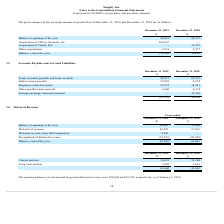According to Shopify's financial document, What is the current portion of deferred revenue in 2019? According to the financial document, 56,691 (in thousands). The relevant text states: "Current portion 56,691 39,180..." Also, What was the January 1, 2018 opening balance of current deferred revenue? According to the financial document, $30,694. The relevant text states: "ces of current and long-term deferred revenue were $30,694 and $1,352, respectively, as of January 1, 2018...." Also, What was the January 1, 2018 opening balance of long-term deferred revenue? According to the financial document, $1,352. The relevant text states: "nt and long-term deferred revenue were $30,694 and $1,352, respectively, as of January 1, 2018...." Also, can you calculate: How much has current deferred revenue changed from January 1, 2018 to December 31, 2018? Based on the calculation: 39,180-30,694, the result is 8486 (in thousands). This is based on the information: "Current portion 56,691 39,180 s of current and long-term deferred revenue were $30,694 and $1,352, respectively, as of January 1, 2018...." The key data points involved are: 30,694, 39,180. Also, can you calculate: How much has long-term deferred revenue changed from January 1, 2018 to December 31, 2018? Based on the calculation: 1,881-1,352, the result is 529 (in thousands). This is based on the information: "Long term portion 5,969 1,881 and long-term deferred revenue were $30,694 and $1,352, respectively, as of January 1, 2018...." The key data points involved are: 1,352, 1,881. Additionally, Between 2018 and 2019, which year had a higher amount of total deferred revenue? According to the financial document, 2019. The relevant text states: "he carrying amount of goodwill as of December 31, 2019 and December 31, 2018 are as follows:..." 